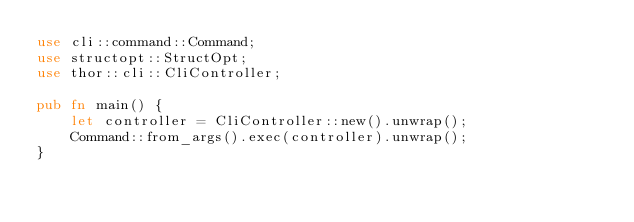Convert code to text. <code><loc_0><loc_0><loc_500><loc_500><_Rust_>use cli::command::Command;
use structopt::StructOpt;
use thor::cli::CliController;

pub fn main() {
    let controller = CliController::new().unwrap();
    Command::from_args().exec(controller).unwrap();
}
</code> 